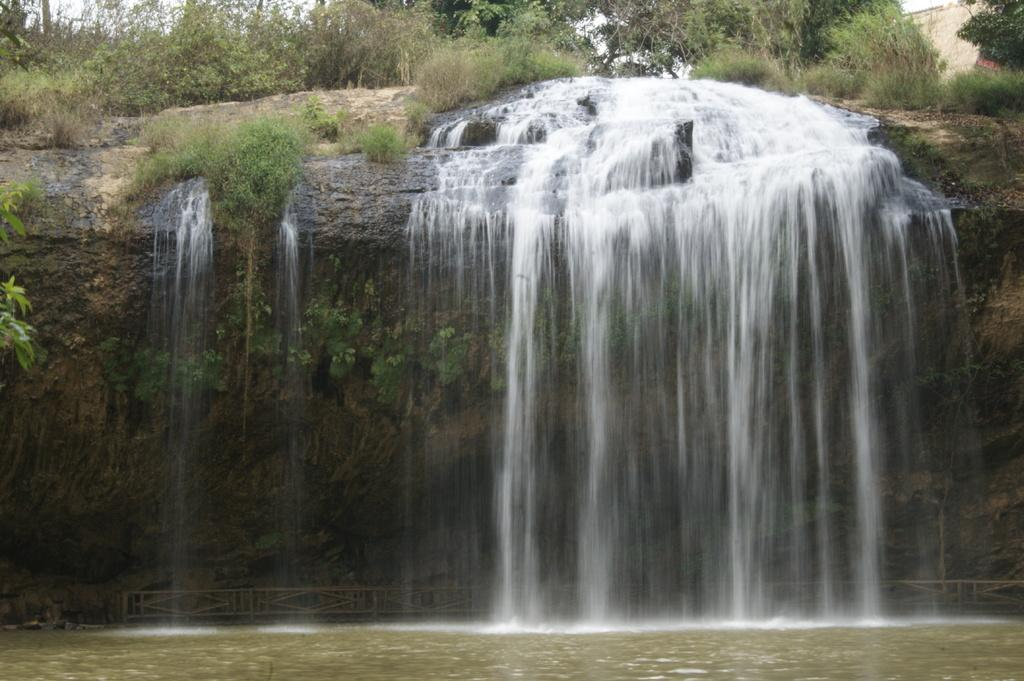What natural feature is the main subject of the image? There is a waterfall in the image. What is located at the bottom of the image? There is a fence and plants at the bottom of the image. What type of vegetation can be seen at the top of the image? There is grass at the top of the image. What is visible in the sky at the top of the image? The sky is visible at the top of the image. Can you tell me how many stars are visible in the image? There are no stars visible in the image; only the waterfall, fence, plants, grass, and sky are present. What type of root can be seen growing near the waterfall in the image? There is no root visible in the image; only the waterfall, fence, plants, grass, and sky are present. 